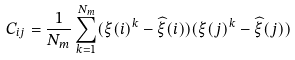Convert formula to latex. <formula><loc_0><loc_0><loc_500><loc_500>C _ { i j } = \frac { 1 } { N _ { m } } \sum _ { k = 1 } ^ { N _ { m } } ( \xi ( i ) ^ { k } - \widehat { \xi } ( i ) ) ( \xi ( j ) ^ { k } - \widehat { \xi } ( j ) )</formula> 